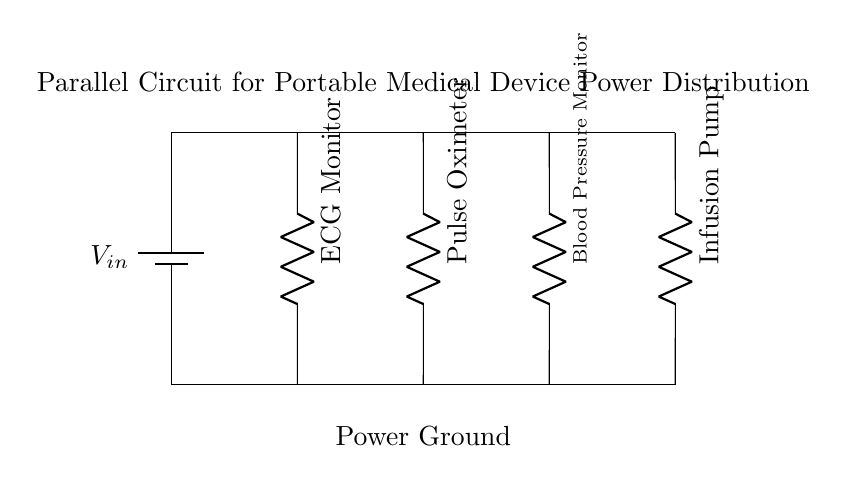What is the power source in this circuit? The power source is represented as a battery symbol labeled V_in. This indicates that the circuit is powered by a battery, which provides the necessary voltage for the operation of the medical devices connected in parallel.
Answer: Battery How many medical devices are connected in parallel? There are four devices shown in the diagram: an ECG monitor, a Pulse Oximeter, a Blood Pressure Monitor, and an Infusion Pump. Each device is connected in parallel to the same power source, allowing them to operate independently.
Answer: Four What is the total voltage supplied to the devices? In a parallel circuit, all devices receive the same voltage as the source. Although the voltage is not specified in the diagram, V_in represents the voltage supply. Hence, the voltage across each device is equal to the battery voltage, which is denoted as V_in.
Answer: V_in Which medical device is connected to the second branch? The second branch from the left is connected to the Pulse Oximeter. The diagram displays the devices in a linear manner, allowing easy identification of which device is connected at each parallel branch.
Answer: Pulse Oximeter What is the benefit of using a parallel circuit in medical devices? The use of a parallel circuit allows each device to operate independently without affecting the operation of others. If one device fails, it does not interrupt the functioning of the others, which is crucial in medical settings where continuous monitoring and operation are vital.
Answer: Independent operation What happens if one device in the circuit fails? If one device fails in a parallel circuit, the others continue to function normally because each device has its own path to the power source. This characteristic of parallel circuits is significant in scenarios where uninterrupted service is required, like in healthcare applications.
Answer: Others continue to operate 